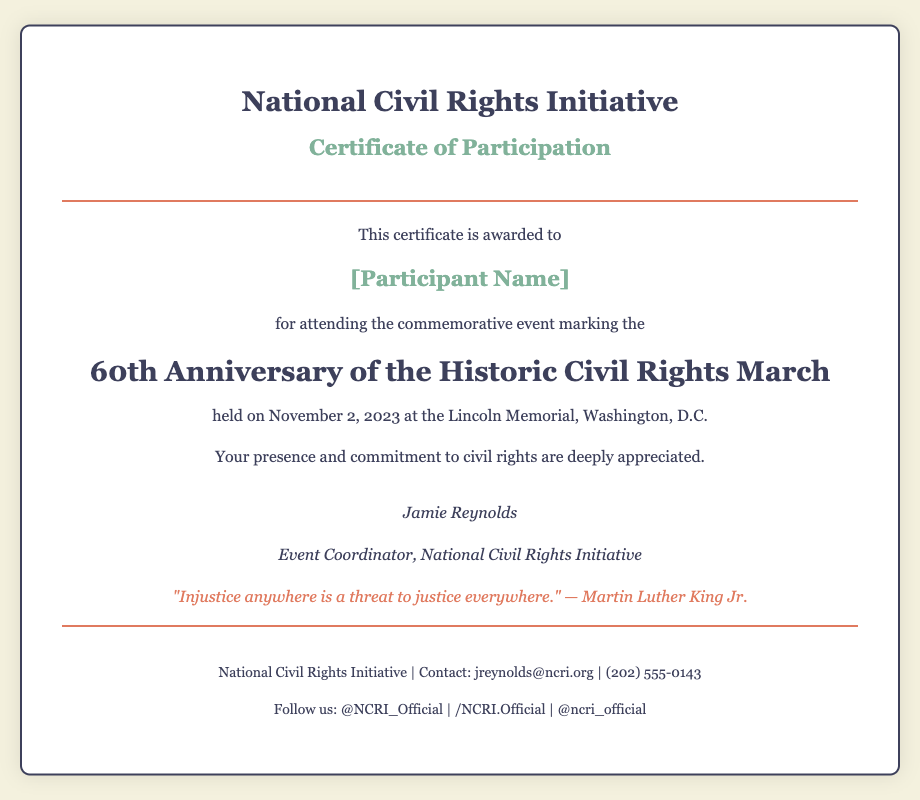what is the name of the initiative? The name of the initiative is stated at the top of the diploma as "National Civil Rights Initiative."
Answer: National Civil Rights Initiative who is the participant of the event? The diploma shows a placeholder for the participant's name as "[Participant Name]."
Answer: [Participant Name] what is the title of the certificate? The title of the certificate is indicated in the document after the initiative name.
Answer: Certificate of Participation when was the anniversary event held? The date of the event is provided in the content section of the diploma.
Answer: November 2, 2023 what is quoted in the diploma? A quote attributed to Martin Luther King Jr. is included in the diploma, which addresses injustice.
Answer: "Injustice anywhere is a threat to justice everywhere." — Martin Luther King Jr who signed the diploma? The signature section names the event coordinator responsible for the diploma.
Answer: Jamie Reynolds where was the event held? The location of the event is specified in the diploma content.
Answer: Lincoln Memorial, Washington, D.C what is the contact email provided? The footer of the diploma includes the contact email for further inquiries.
Answer: jreynolds@ncri.org what is the event's significance? The diploma commemorates a specific historical event related to civil rights, which is evident in the title.
Answer: 60th Anniversary of the Historic Civil Rights March 